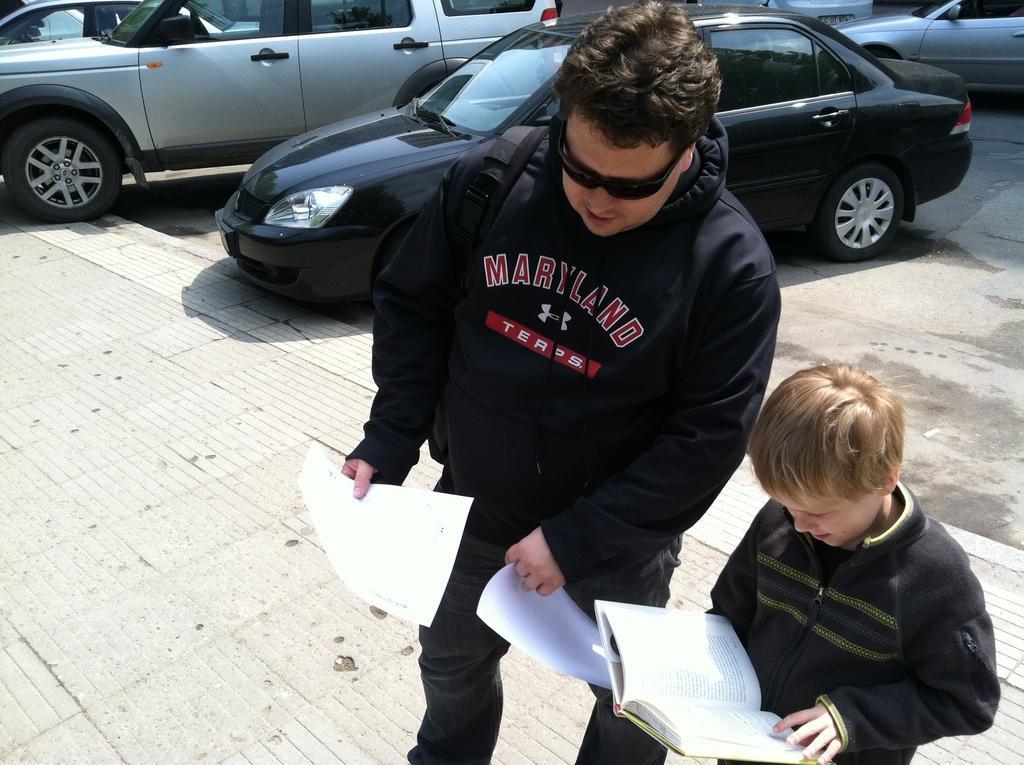Could you give a brief overview of what you see in this image? In this image, there are two persons standing and holding a book and papers. In the background, there are cars on the road. 